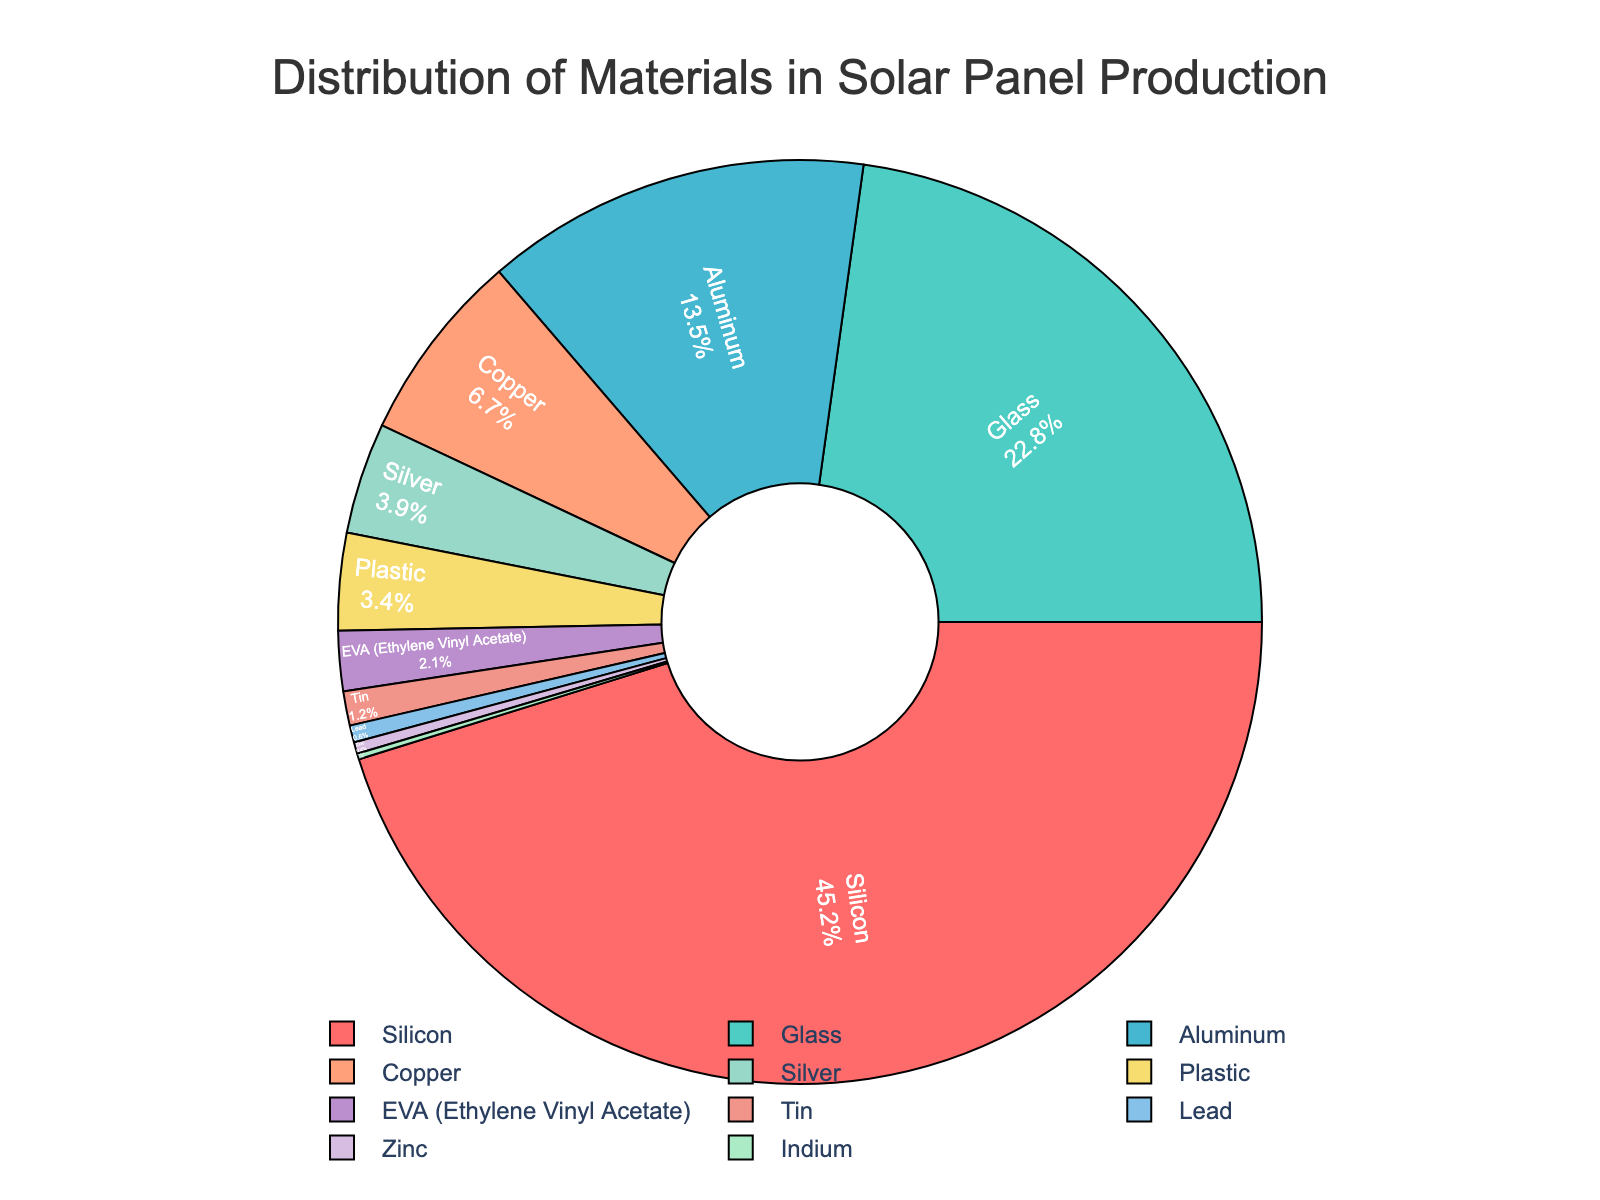What material has the highest usage percentage in solar panel production? The figure indicates that Silicon has the largest slice in the pie chart, taking up 45.2% of the total.
Answer: Silicon Which material has a usage percentage nearly equal to the combined percentage of Silver and Plastic? First, note that Silver is 3.9% and Plastic is 3.4%. Adding these, we get 3.9% + 3.4% = 7.3%. Aluminum is close to this sum with 13.5%.
Answer: Aluminum What is the combined percentage of Silicon, Glass, and Aluminum in solar panel production? Summing up the percentages of these materials: 45.2% (Silicon) + 22.8% (Glass) + 13.5% (Aluminum) = 81.5%.
Answer: 81.5% Which material has a usage percentage less than 1% and is the smallest in solar panel production? The slice for Indium shows 0.2%, which is the smallest percentage on the chart and is less than 1%.
Answer: Indium How much more is the percentage of Copper used compared to Lead? Copper usage is 6.7% and Lead usage is 0.6%. The difference is 6.7% - 0.6% = 6.1%.
Answer: 6.1% Which material's usage percentage is closest to one-tenth of Silicon's usage percentage? Silicon is 45.2%, and one-tenth of this is 4.52%. Silver at 3.9% is the closest to this fraction.
Answer: Silver Are the combined percentages of Copper and Silver greater than that of Glass? Copper is 6.7% and Silver is 3.9%, which adds up to 6.7% + 3.9% = 10.6%. This is less than the 22.8% for Glass.
Answer: No What is the visual color used for EVA (Ethylene Vinyl Acetate) in the pie chart? EVA, according to the chart, has a distinct color among the sections, which is represented visually in peach shade.
Answer: Peach Among Copper, Tin, and Indium, which one occupies the largest share in the pie chart? Copper is 6.7%, Tin is 1.2%, and Indium is 0.2%. Copper has the largest share among these.
Answer: Copper If we combine the usage percentages of Plastic, EVA, Tin, Lead, Zinc, and Indium, what’s their total percentage in the pie chart? Adding them up: 3.4% (Plastic) + 2.1% (EVA) + 1.2% (Tin) + 0.6% (Lead) + 0.4% (Zinc) + 0.2% (Indium) = 7.9%.
Answer: 7.9% 